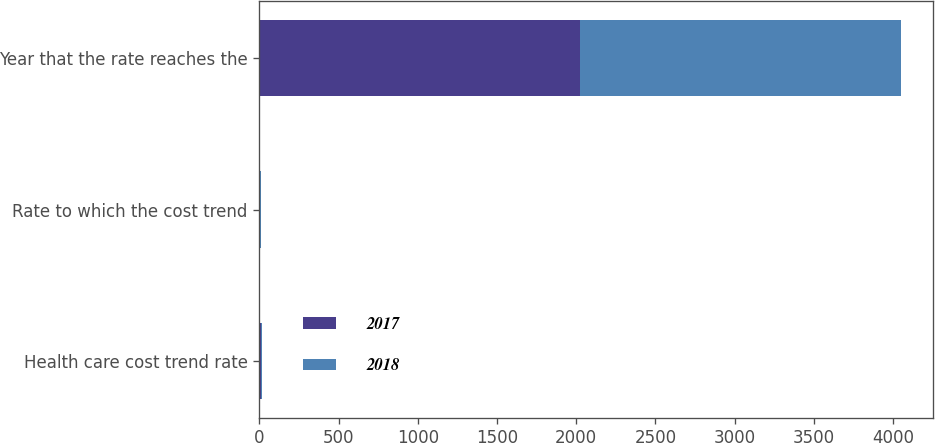Convert chart. <chart><loc_0><loc_0><loc_500><loc_500><stacked_bar_chart><ecel><fcel>Health care cost trend rate<fcel>Rate to which the cost trend<fcel>Year that the rate reaches the<nl><fcel>2017<fcel>7.29<fcel>5<fcel>2026<nl><fcel>2018<fcel>7.3<fcel>5<fcel>2026<nl></chart> 